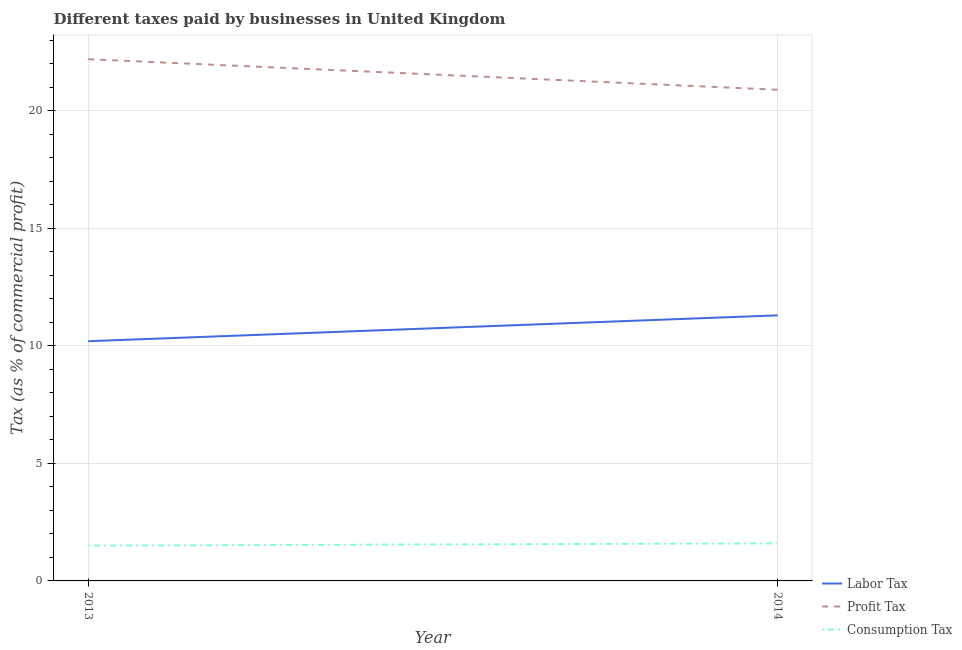How many different coloured lines are there?
Ensure brevity in your answer.  3. Is the number of lines equal to the number of legend labels?
Ensure brevity in your answer.  Yes. What is the percentage of consumption tax in 2014?
Keep it short and to the point. 1.6. Across all years, what is the minimum percentage of profit tax?
Offer a terse response. 20.9. What is the difference between the percentage of labor tax in 2013 and that in 2014?
Ensure brevity in your answer.  -1.1. What is the difference between the percentage of consumption tax in 2013 and the percentage of profit tax in 2014?
Provide a succinct answer. -19.4. What is the average percentage of profit tax per year?
Offer a very short reply. 21.55. What is the ratio of the percentage of profit tax in 2013 to that in 2014?
Offer a very short reply. 1.06. In how many years, is the percentage of profit tax greater than the average percentage of profit tax taken over all years?
Give a very brief answer. 1. Is it the case that in every year, the sum of the percentage of labor tax and percentage of profit tax is greater than the percentage of consumption tax?
Offer a terse response. Yes. Does the percentage of labor tax monotonically increase over the years?
Your answer should be very brief. Yes. Is the percentage of consumption tax strictly greater than the percentage of profit tax over the years?
Ensure brevity in your answer.  No. How many lines are there?
Your answer should be compact. 3. How many years are there in the graph?
Your answer should be very brief. 2. Does the graph contain any zero values?
Offer a very short reply. No. Where does the legend appear in the graph?
Provide a short and direct response. Bottom right. How are the legend labels stacked?
Provide a succinct answer. Vertical. What is the title of the graph?
Offer a very short reply. Different taxes paid by businesses in United Kingdom. Does "Industry" appear as one of the legend labels in the graph?
Your response must be concise. No. What is the label or title of the Y-axis?
Offer a terse response. Tax (as % of commercial profit). What is the Tax (as % of commercial profit) of Labor Tax in 2013?
Offer a terse response. 10.2. What is the Tax (as % of commercial profit) of Consumption Tax in 2013?
Give a very brief answer. 1.5. What is the Tax (as % of commercial profit) in Labor Tax in 2014?
Give a very brief answer. 11.3. What is the Tax (as % of commercial profit) of Profit Tax in 2014?
Provide a succinct answer. 20.9. Across all years, what is the maximum Tax (as % of commercial profit) of Labor Tax?
Give a very brief answer. 11.3. Across all years, what is the maximum Tax (as % of commercial profit) of Profit Tax?
Your answer should be very brief. 22.2. Across all years, what is the maximum Tax (as % of commercial profit) of Consumption Tax?
Your response must be concise. 1.6. Across all years, what is the minimum Tax (as % of commercial profit) in Profit Tax?
Offer a terse response. 20.9. Across all years, what is the minimum Tax (as % of commercial profit) in Consumption Tax?
Keep it short and to the point. 1.5. What is the total Tax (as % of commercial profit) in Profit Tax in the graph?
Make the answer very short. 43.1. What is the difference between the Tax (as % of commercial profit) in Labor Tax in 2013 and that in 2014?
Provide a succinct answer. -1.1. What is the difference between the Tax (as % of commercial profit) in Profit Tax in 2013 and that in 2014?
Offer a terse response. 1.3. What is the difference between the Tax (as % of commercial profit) in Labor Tax in 2013 and the Tax (as % of commercial profit) in Profit Tax in 2014?
Give a very brief answer. -10.7. What is the difference between the Tax (as % of commercial profit) of Labor Tax in 2013 and the Tax (as % of commercial profit) of Consumption Tax in 2014?
Keep it short and to the point. 8.6. What is the difference between the Tax (as % of commercial profit) in Profit Tax in 2013 and the Tax (as % of commercial profit) in Consumption Tax in 2014?
Keep it short and to the point. 20.6. What is the average Tax (as % of commercial profit) of Labor Tax per year?
Make the answer very short. 10.75. What is the average Tax (as % of commercial profit) in Profit Tax per year?
Provide a short and direct response. 21.55. What is the average Tax (as % of commercial profit) of Consumption Tax per year?
Provide a short and direct response. 1.55. In the year 2013, what is the difference between the Tax (as % of commercial profit) in Labor Tax and Tax (as % of commercial profit) in Consumption Tax?
Offer a very short reply. 8.7. In the year 2013, what is the difference between the Tax (as % of commercial profit) of Profit Tax and Tax (as % of commercial profit) of Consumption Tax?
Give a very brief answer. 20.7. In the year 2014, what is the difference between the Tax (as % of commercial profit) in Labor Tax and Tax (as % of commercial profit) in Profit Tax?
Ensure brevity in your answer.  -9.6. In the year 2014, what is the difference between the Tax (as % of commercial profit) of Labor Tax and Tax (as % of commercial profit) of Consumption Tax?
Ensure brevity in your answer.  9.7. In the year 2014, what is the difference between the Tax (as % of commercial profit) of Profit Tax and Tax (as % of commercial profit) of Consumption Tax?
Give a very brief answer. 19.3. What is the ratio of the Tax (as % of commercial profit) in Labor Tax in 2013 to that in 2014?
Provide a short and direct response. 0.9. What is the ratio of the Tax (as % of commercial profit) in Profit Tax in 2013 to that in 2014?
Offer a terse response. 1.06. What is the ratio of the Tax (as % of commercial profit) in Consumption Tax in 2013 to that in 2014?
Offer a terse response. 0.94. What is the difference between the highest and the second highest Tax (as % of commercial profit) of Labor Tax?
Offer a very short reply. 1.1. What is the difference between the highest and the second highest Tax (as % of commercial profit) in Profit Tax?
Make the answer very short. 1.3. What is the difference between the highest and the lowest Tax (as % of commercial profit) in Profit Tax?
Provide a succinct answer. 1.3. What is the difference between the highest and the lowest Tax (as % of commercial profit) in Consumption Tax?
Keep it short and to the point. 0.1. 